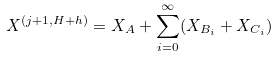<formula> <loc_0><loc_0><loc_500><loc_500>X ^ { ( j + 1 , H + h ) } = X _ { A } + \sum _ { i = 0 } ^ { \infty } ( X _ { B _ { i } } + X _ { C _ { i } } )</formula> 